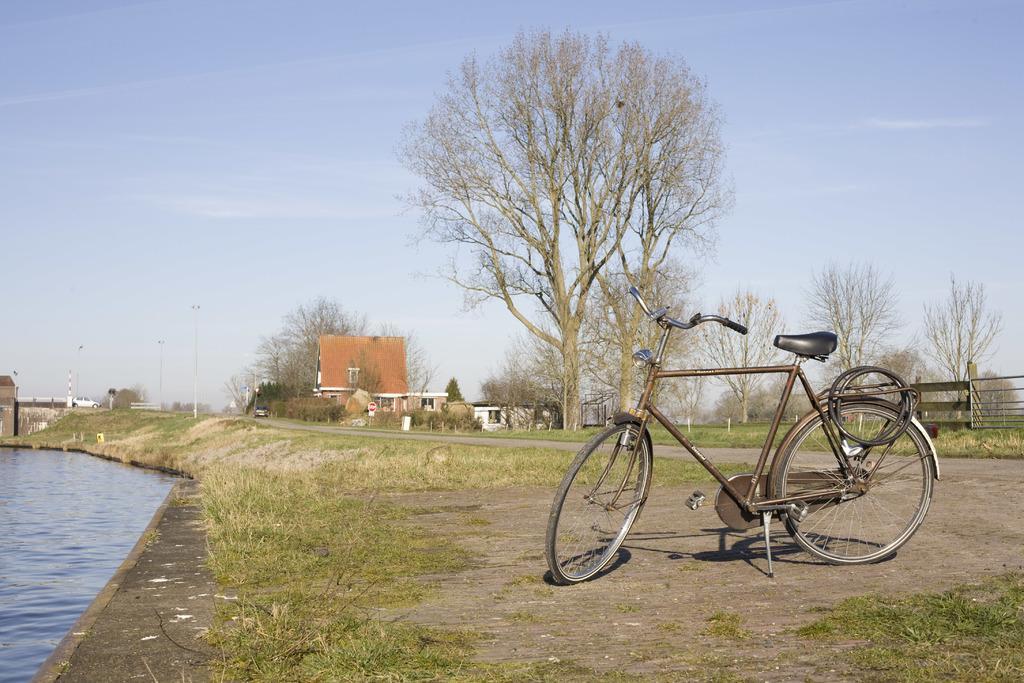Could you give a brief overview of what you see in this image? In this image, we can see some water. We can see some grass and trees. We can see the ground with some objects. There are a few houses and vehicles. We can see a bicycle. We can see some poles and objects on the right. We can see some boards and the sky with clouds. 